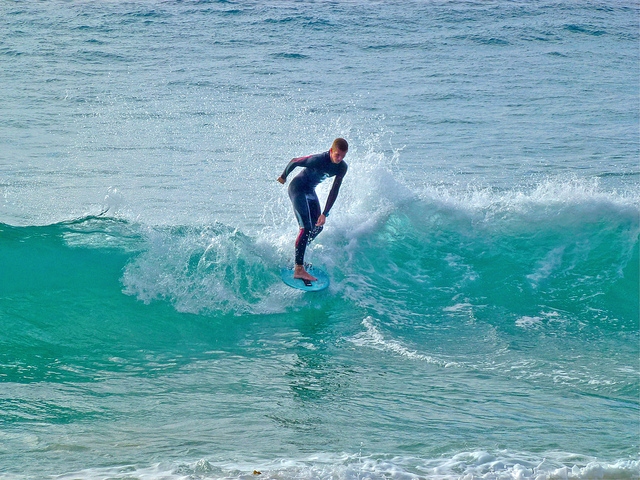<image>What color hat is the man wearing? The man is not wearing a hat in the image. What color hat is the man wearing? I am not sure what color hat the man is wearing as there is no hat in the image. 